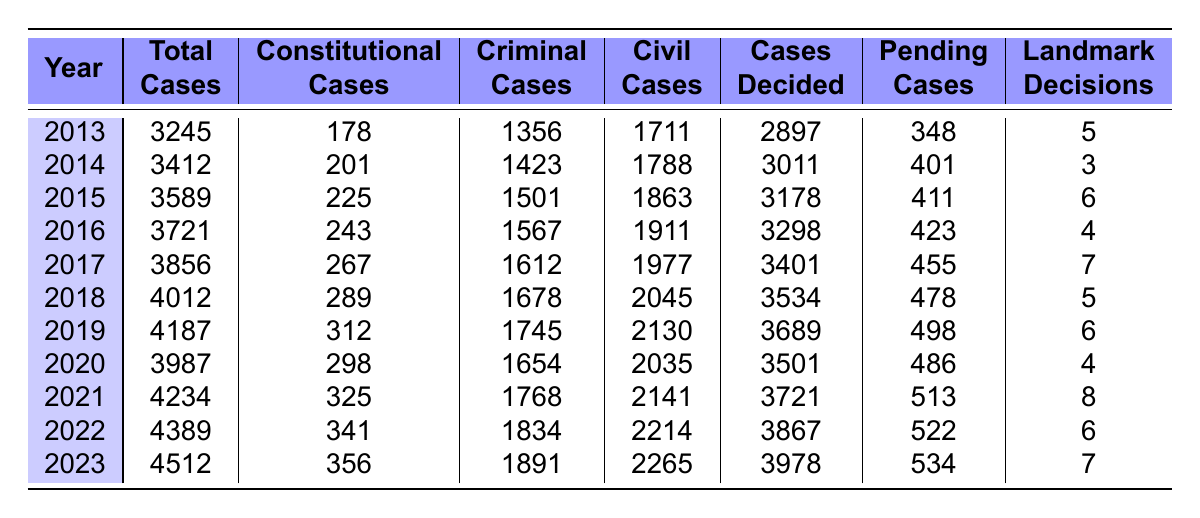What is the total number of cases decided in 2021? In 2021, the table shows that 3721 cases were decided.
Answer: 3721 Which year had the highest number of pending cases? The highest number of pending cases is 534, which occurred in 2023.
Answer: 2023 How many landmark decisions were made on average per year from 2013 to 2023? The total number of landmark decisions over the 11 years is 58 (5+3+6+4+7+5+6+4+8+6+7). Dividing 58 by 11 gives an average of approximately 5.27, which rounds to 5.3.
Answer: 5.3 Did the number of constitutional cases decided increase from 2013 to 2023? Yes, the number of constitutional cases increased from 178 in 2013 to 356 in 2023.
Answer: Yes What is the difference between the total cases filed in 2019 and 2020? In 2019, there were 4187 total cases, and in 2020 there were 3987. The difference is 4187 - 3987 = 200.
Answer: 200 What was the average number of civil cases decided each year from 2013 to 2023? The total number of civil cases decided is 18685 (1711 + 1788 + 1863 + 1911 + 1977 + 2045 + 2130 + 2035 + 2141 + 2214 + 2265). Dividing this by 11 gives an average of approximately 1698.64, which rounds to 1699.
Answer: 1699 Was there a year when the number of criminal cases was less than 1500? No, from the data, every year from 2013 to 2023 had criminal cases ranging from 1356 to 1891, with 2013 being the only year below 1500.
Answer: Yes What is the trend in the number of total cases filed from 2013 to 2023? The total cases filed show a consistent increase each year from 3245 in 2013 to 4512 in 2023.
Answer: Increasing In which year did the number of landmark decisions reach its peak? The peak number of landmark decisions, which is 8, was reached in 2021.
Answer: 2021 How many more civil cases than constitutional cases were decided in 2022? In 2022, 3867 civil cases and 341 constitutional cases were decided. The difference is 3867 - 341 = 3526.
Answer: 3526 Is it true that the number of landmark decisions decreased in 2020 compared to 2019? Yes, the number of landmark decisions was 6 in 2019 but decreased to 4 in 2020.
Answer: Yes 